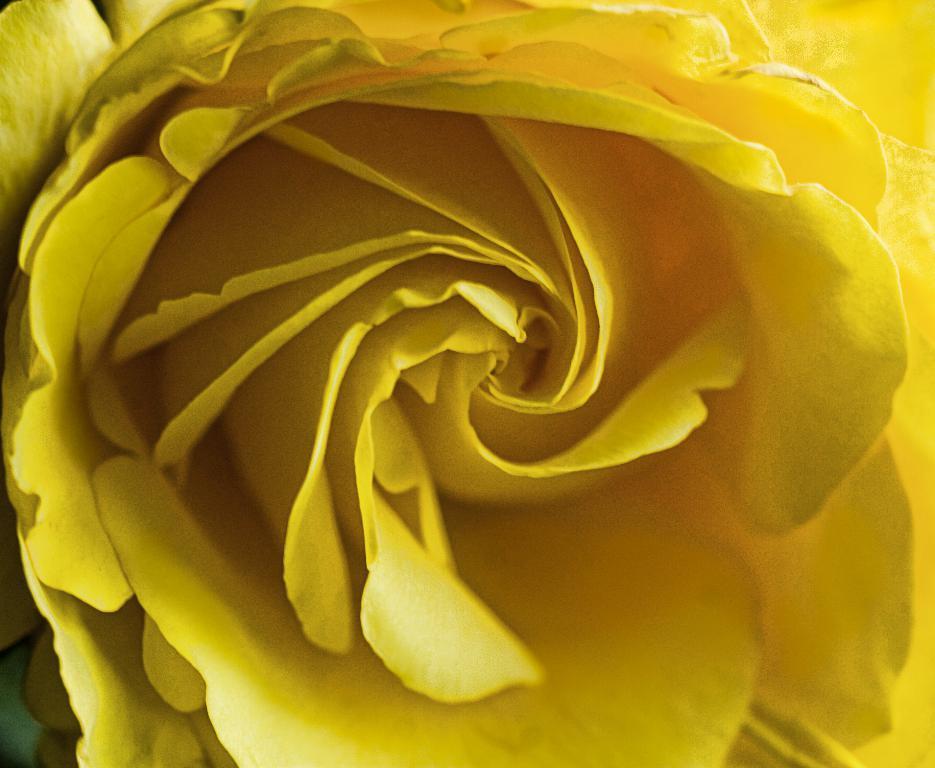Can you describe this image briefly? In this image, we can see a flower which is in yellow color. 